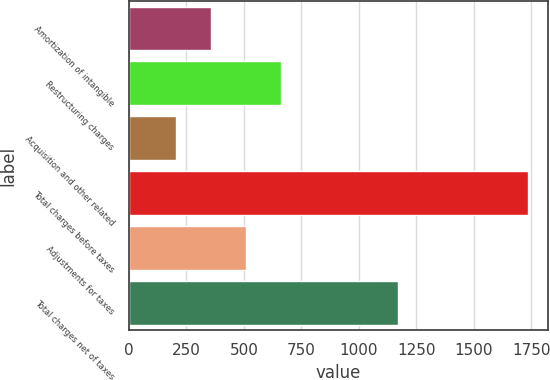<chart> <loc_0><loc_0><loc_500><loc_500><bar_chart><fcel>Amortization of intangible<fcel>Restructuring charges<fcel>Acquisition and other related<fcel>Total charges before taxes<fcel>Adjustments for taxes<fcel>Total charges net of taxes<nl><fcel>356.2<fcel>662.6<fcel>203<fcel>1735<fcel>509.4<fcel>1172<nl></chart> 